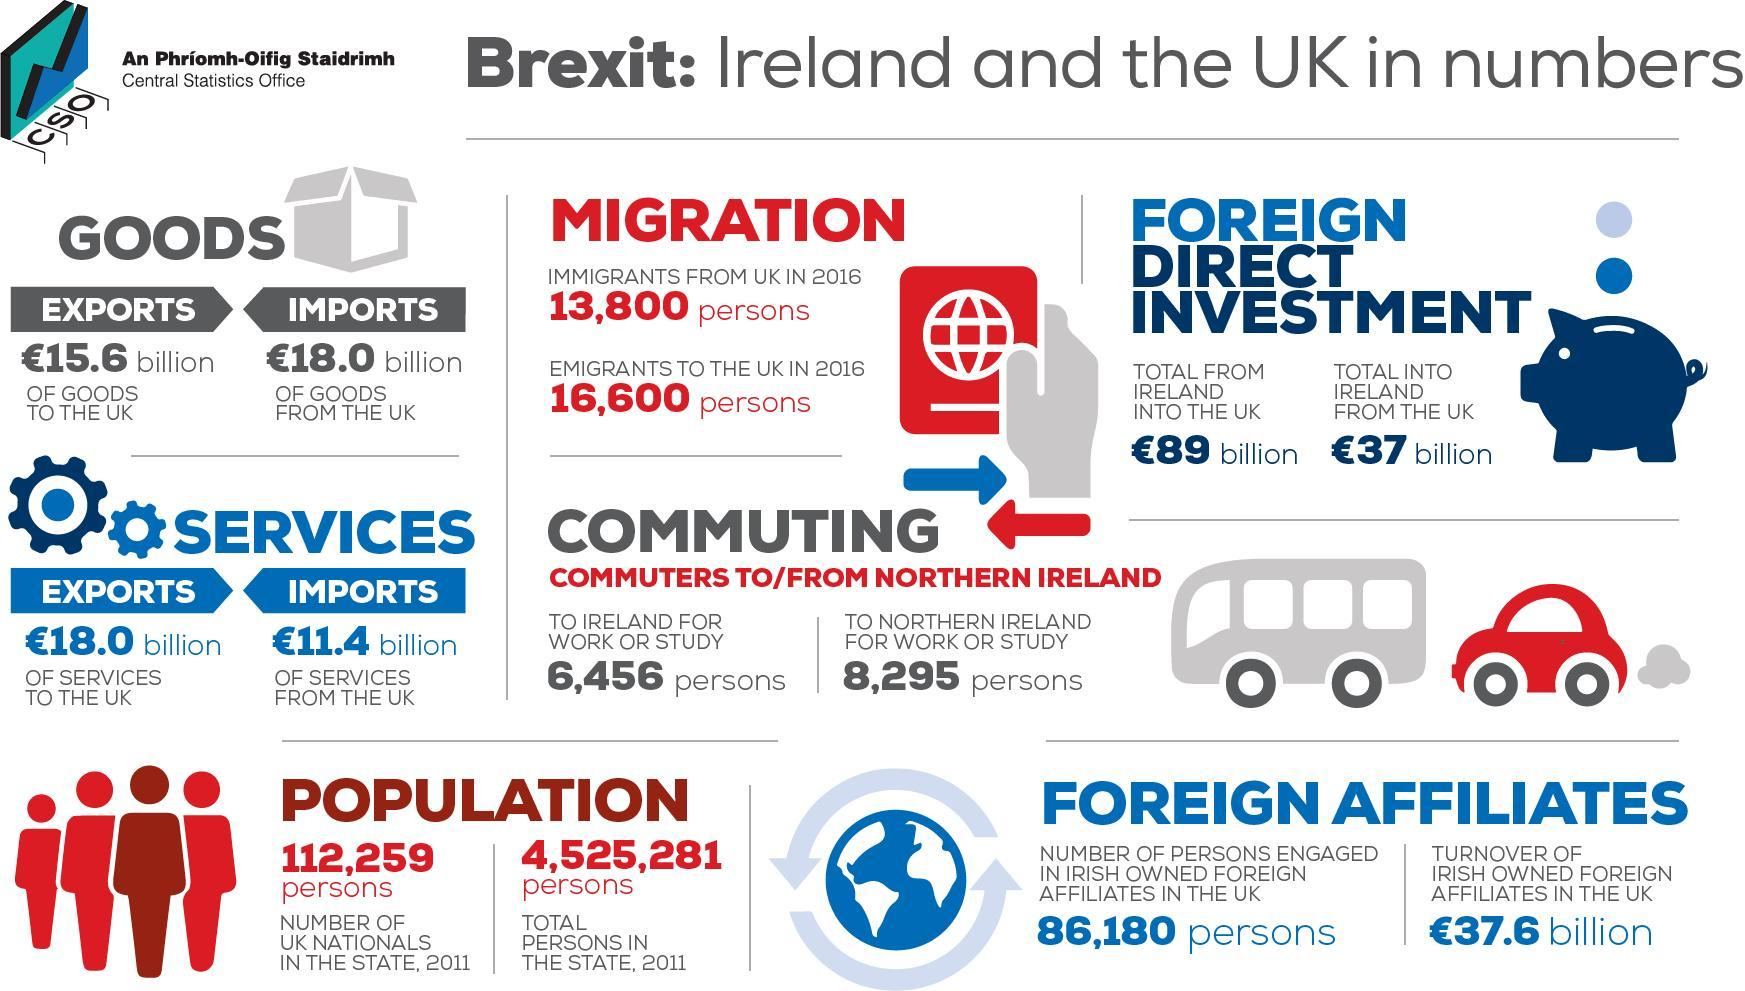What is the amount of import of services in pounds from the UK?
Answer the question with a short phrase. 11.4 billion How much is the quantity of goods imported in pounds from UK? 18.0 billion What is the number of people going to northern Ireland for job or learning? 8,295 persons What is the number of Emigrants to UK in 2016? 16,600 What is the population of Ireland alone without UK nationals in the state? 44,13,022 What is the amount of Foreign Direct Investment in pounds from Ireland into UK? 89 billion What is the amount of Foreign Direct Investment in pounds from UK into Ireland? 37 billion 